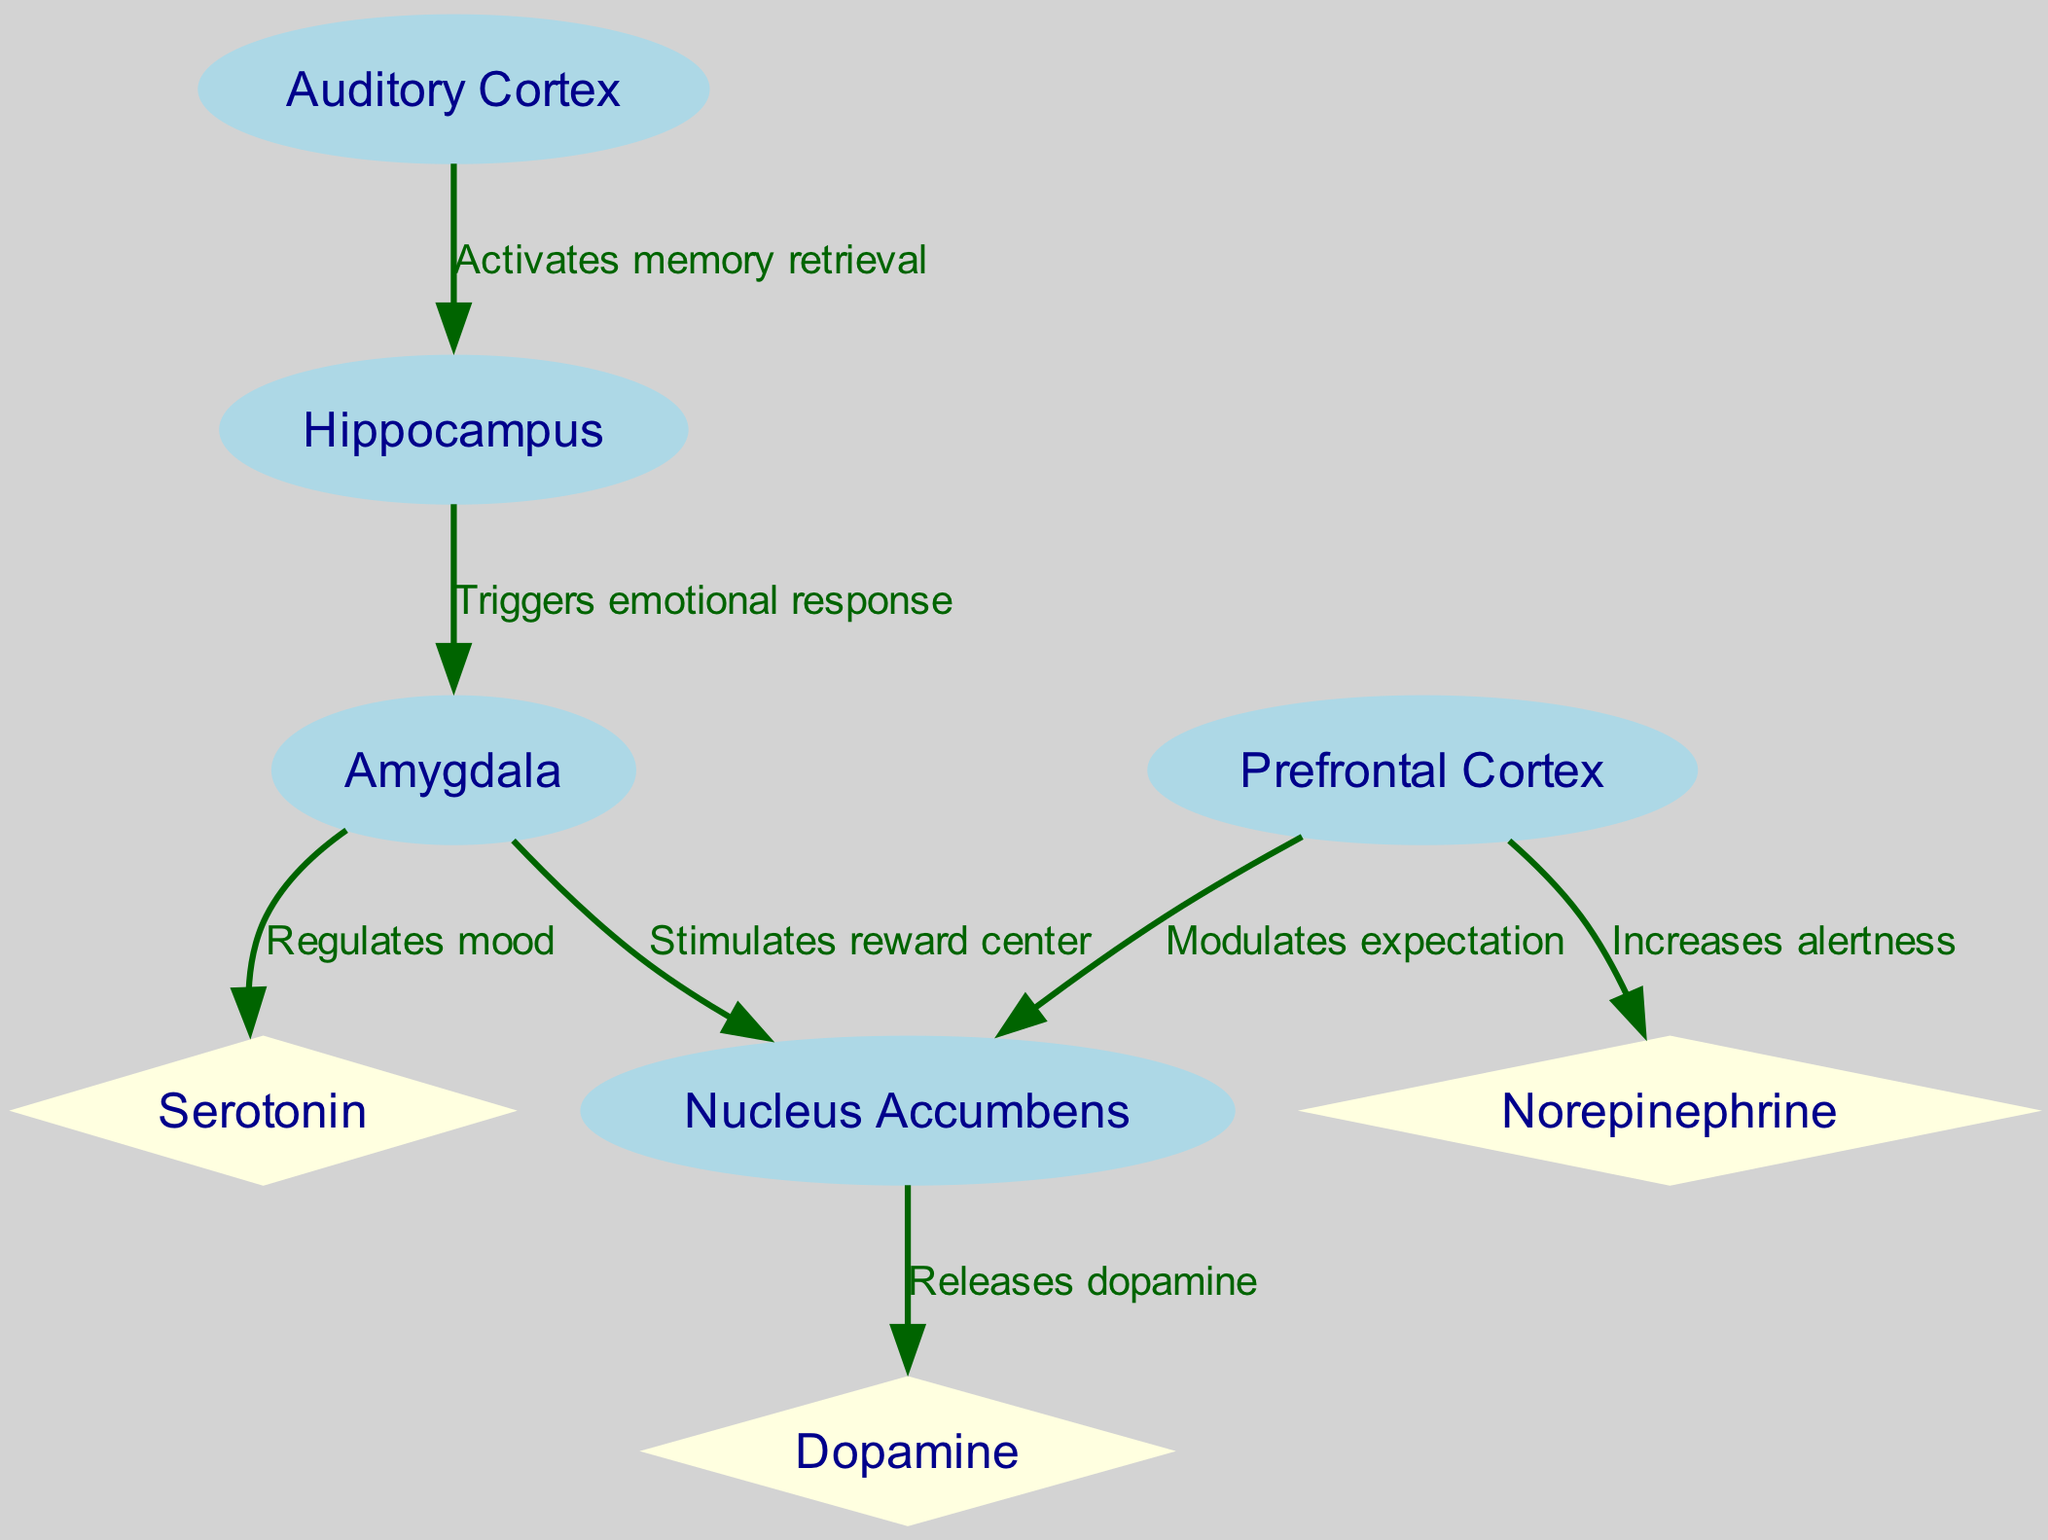What is the total number of nodes in the diagram? The diagram contains a list of nodes that can be counted: Auditory Cortex, Hippocampus, Amygdala, Nucleus Accumbens, Prefrontal Cortex, Dopamine, Serotonin, and Norepinephrine. Counting these nodes yields a total of 8 nodes.
Answer: 8 Which node activates memory retrieval? According to the diagram, the node labeled "Auditory Cortex" is directly linked to "Hippocampus" with the label "Activates memory retrieval," indicating it is responsible for activating memory retrieval.
Answer: Auditory Cortex How many edges are there in the diagram? The edges represent the connections between nodes. By counting all listed edges, such as those from Auditory Cortex to Hippocampus, Hippocampus to Amygdala, etc., we find a total of 7 edges present.
Answer: 7 What triggers an emotional response in the brain? The diagram shows that the "Hippocampus" has a direct relationship with "Amygdala," with the edge labeled "Triggers emotional response," establishing the Hippocampus as the trigger for emotional responses.
Answer: Hippocampus How does the Prefrontal Cortex influence anticipation? The edge from "Prefrontal Cortex" to "Nucleus Accumbens," labeled "Modulates expectation," indicates that the Prefrontal Cortex plays a role in modulating anticipation related to expected rewards, such as those from a new album.
Answer: Modulates expectation Which neurotransmitter is released by the Nucleus Accumbens? The diagram indicates an edge from "Nucleus Accumbens" to "Dopamine" labeled "Releases dopamine," showing that dopamine is the neurotransmitter released by the Nucleus Accumbens.
Answer: Dopamine How does the Amygdala affect mood? The diagram indicates that there is a direct relationship from "Amygdala" to "Serotonin" labeled "Regulates mood." This suggests that the Amygdala has a regulatory effect on mood through serotonin.
Answer: Regulates mood What effect does the Prefrontal Cortex have on alertness? According to the diagram, the "Prefrontal Cortex" connects to "Norepinephrine" with the edge labeled "Increases alertness," establishing its influence in increasing alertness through norepinephrine.
Answer: Increases alertness 